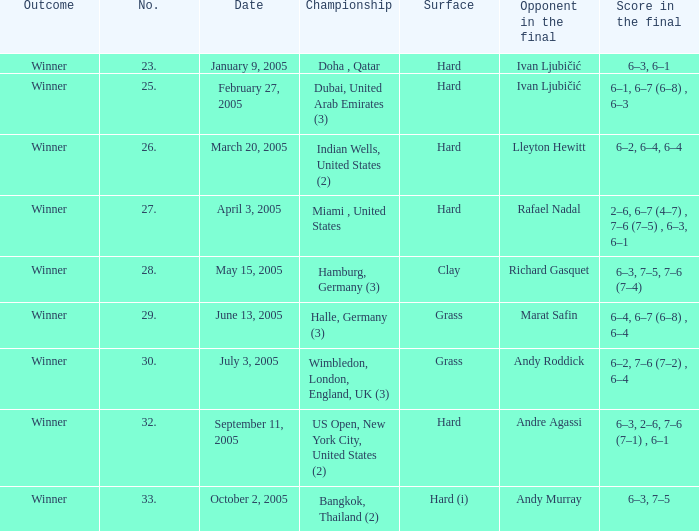Andy Roddick is the opponent in the final on what surface? Grass. 